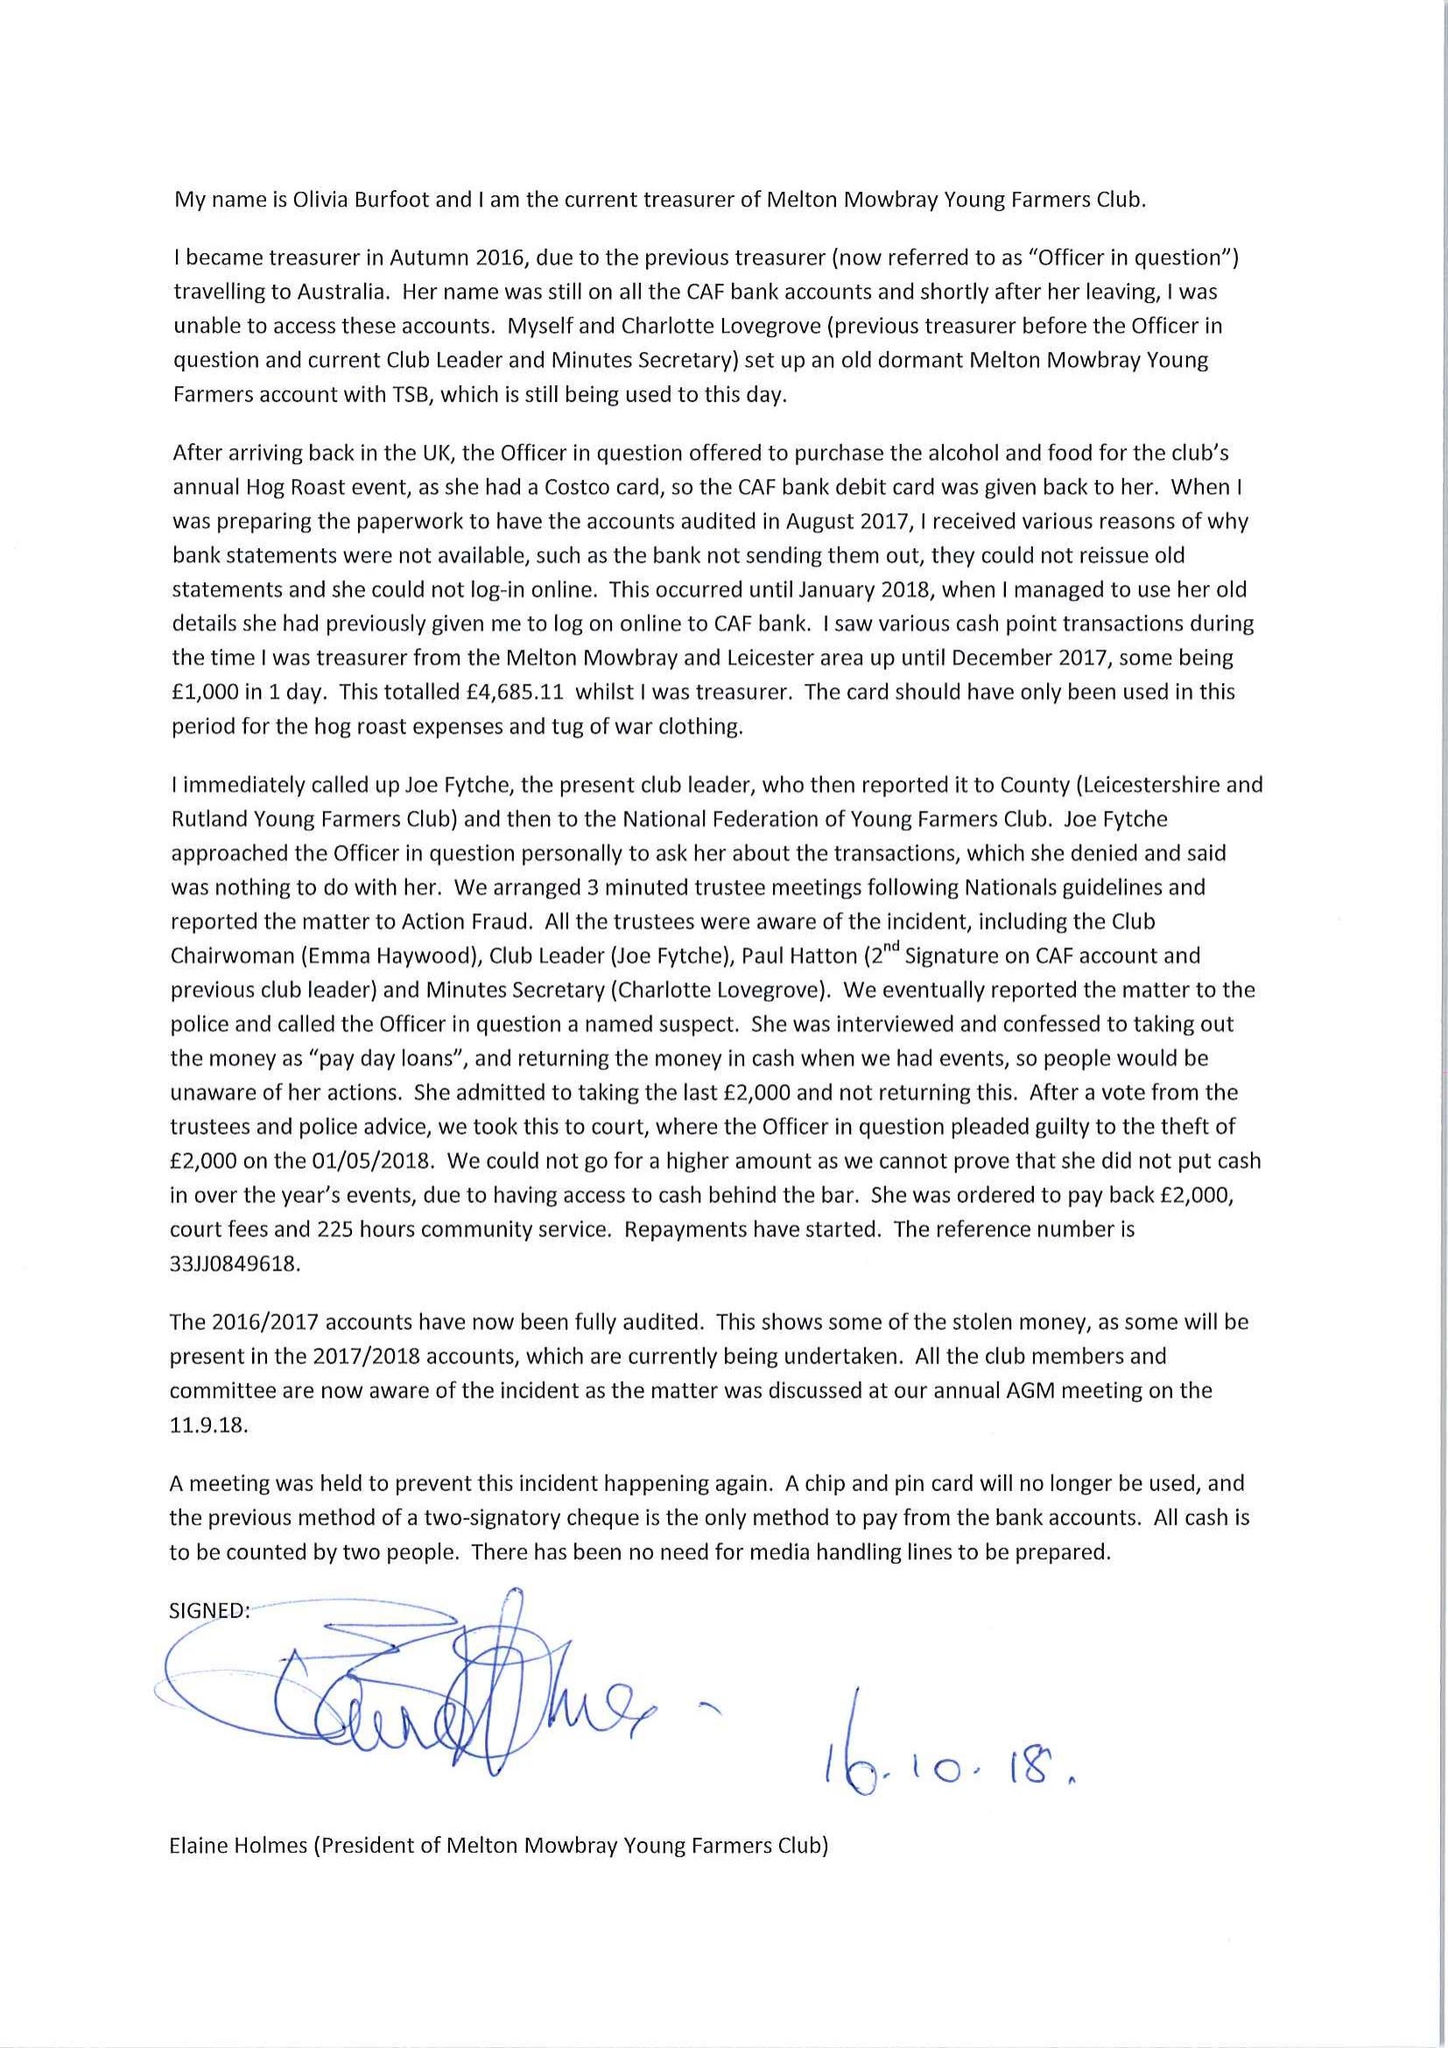What is the value for the address__street_line?
Answer the question using a single word or phrase. None 